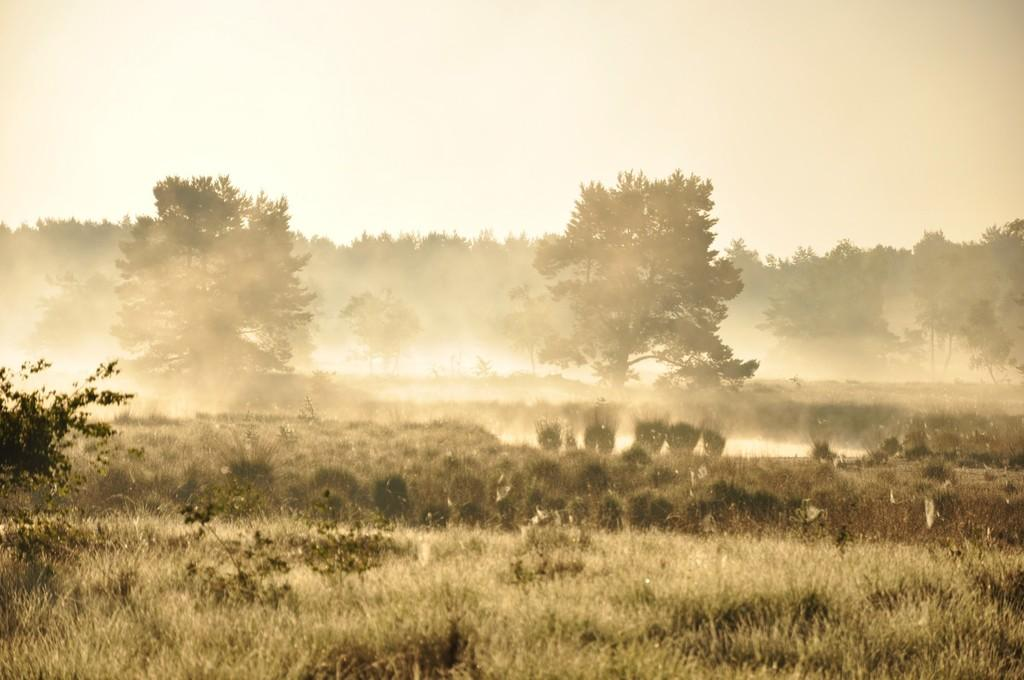What type of vegetation is at the bottom of the image? There is grass at the bottom of the image. What can be seen in the middle of the image? There are trees in the middle of the image. What atmospheric condition is visible in the image? Fog is visible in the image. What is visible at the top of the image? The sky is visible at the top of the image. What class is being taught in the image? There is no class or educational setting present in the image. How does the fog mark the beginning of the journey in the image? The image does not depict a journey or any indication of a starting point. 